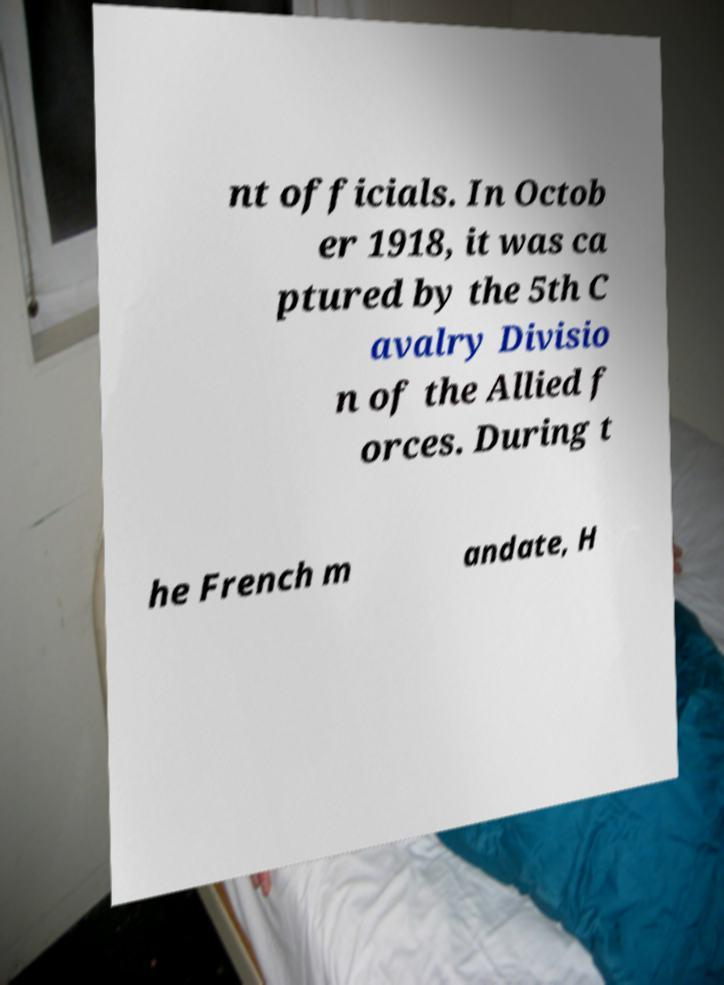Please read and relay the text visible in this image. What does it say? nt officials. In Octob er 1918, it was ca ptured by the 5th C avalry Divisio n of the Allied f orces. During t he French m andate, H 